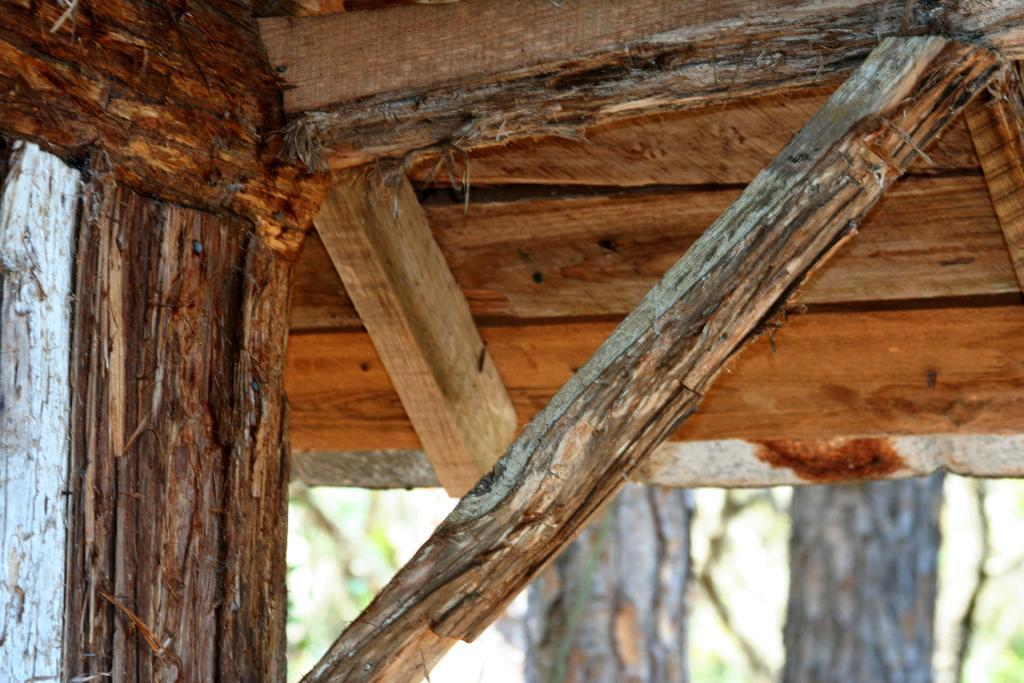How would you summarize this image in a sentence or two? In this image there is a roof having few wooden planks attached to it. Bottom of the image there are few trees. 